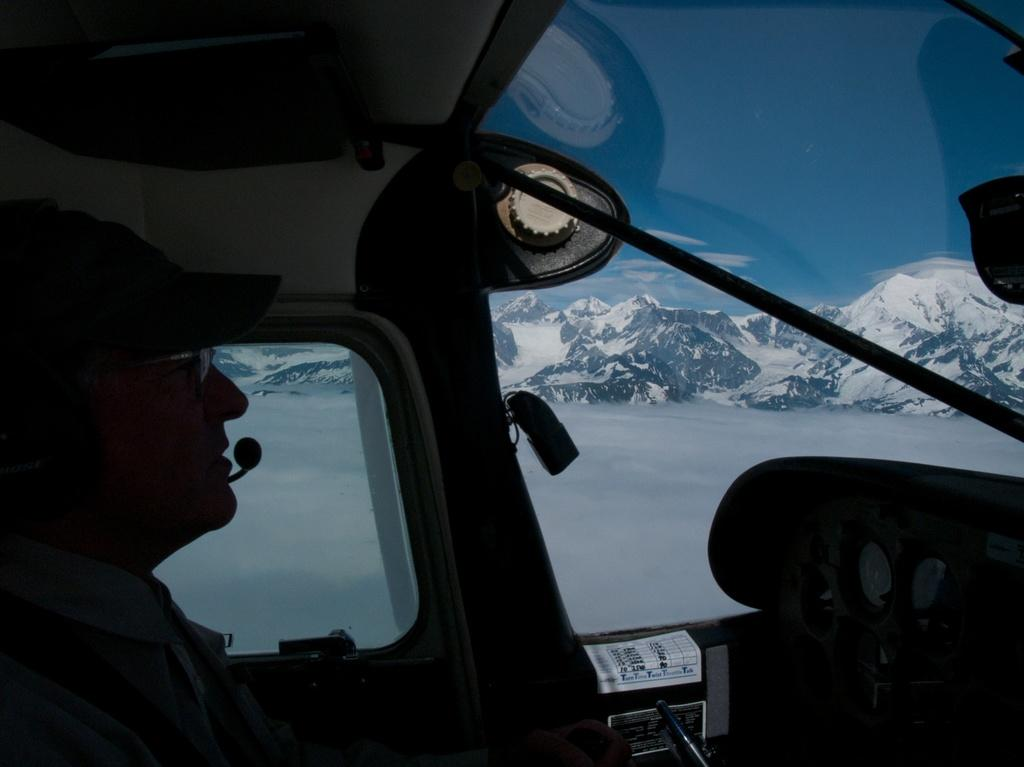What is the perspective of the image? The image is captured from inside a vehicle. Who is controlling the vehicle? There is a pilot moving the vehicle. What can be seen in the background of the image? There are mountains covered with snow in the background. What type of cakes are being sold in the downtown area in the image? There is no downtown area or cakes present in the image; it is captured from inside a vehicle with a pilot and snow-covered mountains in the background. 